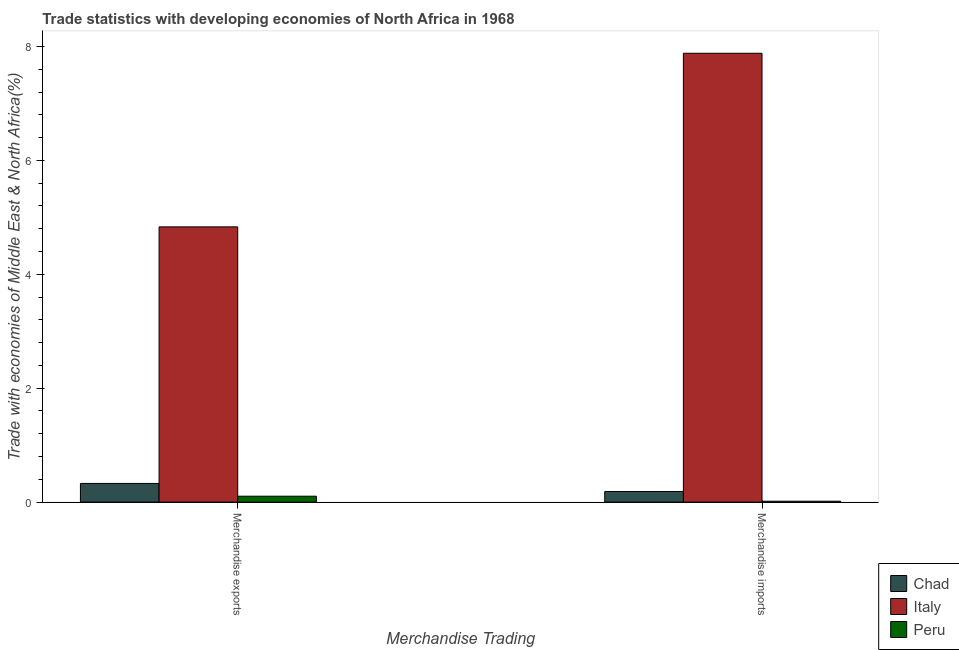How many different coloured bars are there?
Your response must be concise. 3. How many groups of bars are there?
Provide a succinct answer. 2. How many bars are there on the 1st tick from the right?
Make the answer very short. 3. What is the merchandise imports in Italy?
Your answer should be very brief. 7.88. Across all countries, what is the maximum merchandise imports?
Your answer should be very brief. 7.88. Across all countries, what is the minimum merchandise imports?
Offer a very short reply. 0.02. In which country was the merchandise imports maximum?
Your answer should be very brief. Italy. What is the total merchandise imports in the graph?
Offer a very short reply. 8.08. What is the difference between the merchandise exports in Italy and that in Chad?
Provide a succinct answer. 4.5. What is the difference between the merchandise exports in Peru and the merchandise imports in Chad?
Offer a very short reply. -0.08. What is the average merchandise exports per country?
Make the answer very short. 1.75. What is the difference between the merchandise imports and merchandise exports in Chad?
Offer a terse response. -0.14. What is the ratio of the merchandise exports in Italy to that in Chad?
Provide a short and direct response. 14.74. In how many countries, is the merchandise imports greater than the average merchandise imports taken over all countries?
Your answer should be compact. 1. What does the 1st bar from the left in Merchandise imports represents?
Your answer should be very brief. Chad. Are the values on the major ticks of Y-axis written in scientific E-notation?
Keep it short and to the point. No. What is the title of the graph?
Your answer should be very brief. Trade statistics with developing economies of North Africa in 1968. What is the label or title of the X-axis?
Provide a succinct answer. Merchandise Trading. What is the label or title of the Y-axis?
Your response must be concise. Trade with economies of Middle East & North Africa(%). What is the Trade with economies of Middle East & North Africa(%) of Chad in Merchandise exports?
Your response must be concise. 0.33. What is the Trade with economies of Middle East & North Africa(%) in Italy in Merchandise exports?
Your response must be concise. 4.83. What is the Trade with economies of Middle East & North Africa(%) in Peru in Merchandise exports?
Your answer should be very brief. 0.1. What is the Trade with economies of Middle East & North Africa(%) of Chad in Merchandise imports?
Your answer should be very brief. 0.19. What is the Trade with economies of Middle East & North Africa(%) of Italy in Merchandise imports?
Give a very brief answer. 7.88. What is the Trade with economies of Middle East & North Africa(%) of Peru in Merchandise imports?
Keep it short and to the point. 0.02. Across all Merchandise Trading, what is the maximum Trade with economies of Middle East & North Africa(%) in Chad?
Your answer should be very brief. 0.33. Across all Merchandise Trading, what is the maximum Trade with economies of Middle East & North Africa(%) in Italy?
Ensure brevity in your answer.  7.88. Across all Merchandise Trading, what is the maximum Trade with economies of Middle East & North Africa(%) in Peru?
Keep it short and to the point. 0.1. Across all Merchandise Trading, what is the minimum Trade with economies of Middle East & North Africa(%) in Chad?
Make the answer very short. 0.19. Across all Merchandise Trading, what is the minimum Trade with economies of Middle East & North Africa(%) in Italy?
Ensure brevity in your answer.  4.83. Across all Merchandise Trading, what is the minimum Trade with economies of Middle East & North Africa(%) in Peru?
Your answer should be compact. 0.02. What is the total Trade with economies of Middle East & North Africa(%) of Chad in the graph?
Ensure brevity in your answer.  0.51. What is the total Trade with economies of Middle East & North Africa(%) in Italy in the graph?
Offer a terse response. 12.71. What is the total Trade with economies of Middle East & North Africa(%) of Peru in the graph?
Offer a very short reply. 0.12. What is the difference between the Trade with economies of Middle East & North Africa(%) in Chad in Merchandise exports and that in Merchandise imports?
Give a very brief answer. 0.14. What is the difference between the Trade with economies of Middle East & North Africa(%) of Italy in Merchandise exports and that in Merchandise imports?
Your answer should be compact. -3.05. What is the difference between the Trade with economies of Middle East & North Africa(%) of Peru in Merchandise exports and that in Merchandise imports?
Provide a succinct answer. 0.09. What is the difference between the Trade with economies of Middle East & North Africa(%) of Chad in Merchandise exports and the Trade with economies of Middle East & North Africa(%) of Italy in Merchandise imports?
Offer a very short reply. -7.55. What is the difference between the Trade with economies of Middle East & North Africa(%) in Chad in Merchandise exports and the Trade with economies of Middle East & North Africa(%) in Peru in Merchandise imports?
Offer a very short reply. 0.31. What is the difference between the Trade with economies of Middle East & North Africa(%) in Italy in Merchandise exports and the Trade with economies of Middle East & North Africa(%) in Peru in Merchandise imports?
Your response must be concise. 4.82. What is the average Trade with economies of Middle East & North Africa(%) of Chad per Merchandise Trading?
Offer a very short reply. 0.26. What is the average Trade with economies of Middle East & North Africa(%) in Italy per Merchandise Trading?
Provide a short and direct response. 6.36. What is the average Trade with economies of Middle East & North Africa(%) of Peru per Merchandise Trading?
Your answer should be compact. 0.06. What is the difference between the Trade with economies of Middle East & North Africa(%) of Chad and Trade with economies of Middle East & North Africa(%) of Italy in Merchandise exports?
Provide a succinct answer. -4.5. What is the difference between the Trade with economies of Middle East & North Africa(%) of Chad and Trade with economies of Middle East & North Africa(%) of Peru in Merchandise exports?
Your response must be concise. 0.22. What is the difference between the Trade with economies of Middle East & North Africa(%) in Italy and Trade with economies of Middle East & North Africa(%) in Peru in Merchandise exports?
Provide a succinct answer. 4.73. What is the difference between the Trade with economies of Middle East & North Africa(%) of Chad and Trade with economies of Middle East & North Africa(%) of Italy in Merchandise imports?
Your answer should be compact. -7.69. What is the difference between the Trade with economies of Middle East & North Africa(%) of Chad and Trade with economies of Middle East & North Africa(%) of Peru in Merchandise imports?
Give a very brief answer. 0.17. What is the difference between the Trade with economies of Middle East & North Africa(%) of Italy and Trade with economies of Middle East & North Africa(%) of Peru in Merchandise imports?
Make the answer very short. 7.86. What is the ratio of the Trade with economies of Middle East & North Africa(%) of Chad in Merchandise exports to that in Merchandise imports?
Offer a very short reply. 1.76. What is the ratio of the Trade with economies of Middle East & North Africa(%) in Italy in Merchandise exports to that in Merchandise imports?
Offer a terse response. 0.61. What is the ratio of the Trade with economies of Middle East & North Africa(%) in Peru in Merchandise exports to that in Merchandise imports?
Ensure brevity in your answer.  6.57. What is the difference between the highest and the second highest Trade with economies of Middle East & North Africa(%) of Chad?
Provide a short and direct response. 0.14. What is the difference between the highest and the second highest Trade with economies of Middle East & North Africa(%) of Italy?
Your response must be concise. 3.05. What is the difference between the highest and the second highest Trade with economies of Middle East & North Africa(%) in Peru?
Make the answer very short. 0.09. What is the difference between the highest and the lowest Trade with economies of Middle East & North Africa(%) of Chad?
Make the answer very short. 0.14. What is the difference between the highest and the lowest Trade with economies of Middle East & North Africa(%) of Italy?
Provide a short and direct response. 3.05. What is the difference between the highest and the lowest Trade with economies of Middle East & North Africa(%) in Peru?
Offer a very short reply. 0.09. 